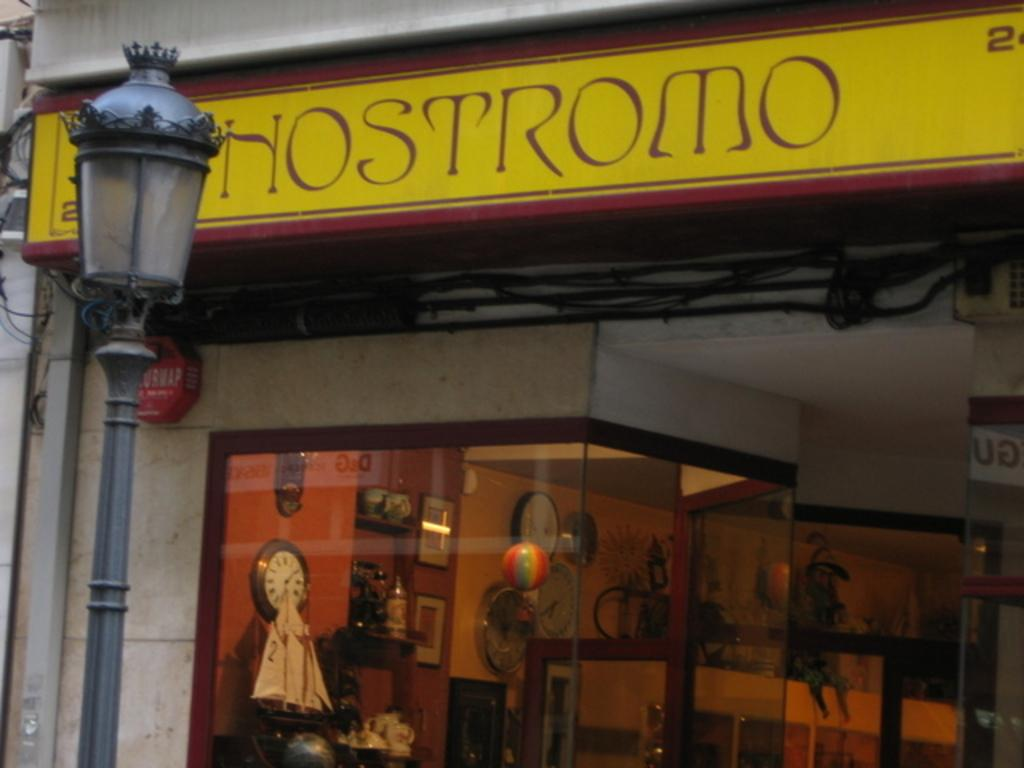<image>
Summarize the visual content of the image. A yellow sign for a business that reads "HOSTROMO" in maroon colored writing. 